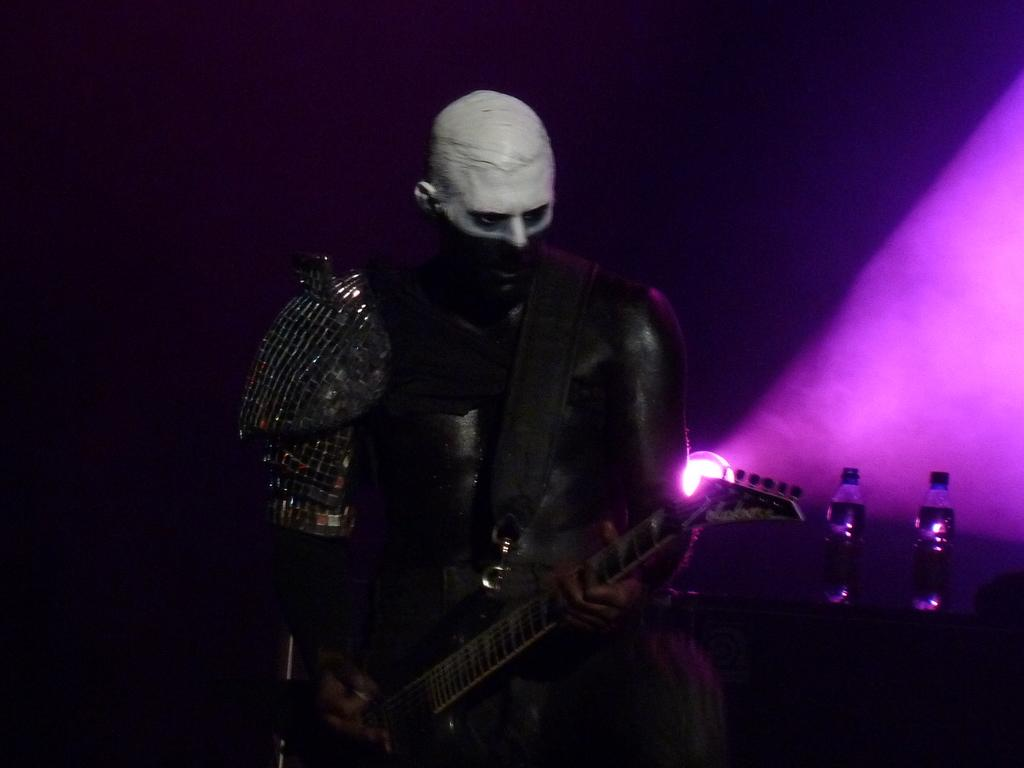Who is the main subject in the image? There is a man in the image. What is the man doing in the image? The man is playing a guitar. Where is the man located in the image? The man is on a stage. What emotion does the man express while playing the guitar in the alley? There is no alley present in the image, and the man's emotions cannot be determined from the image alone. 